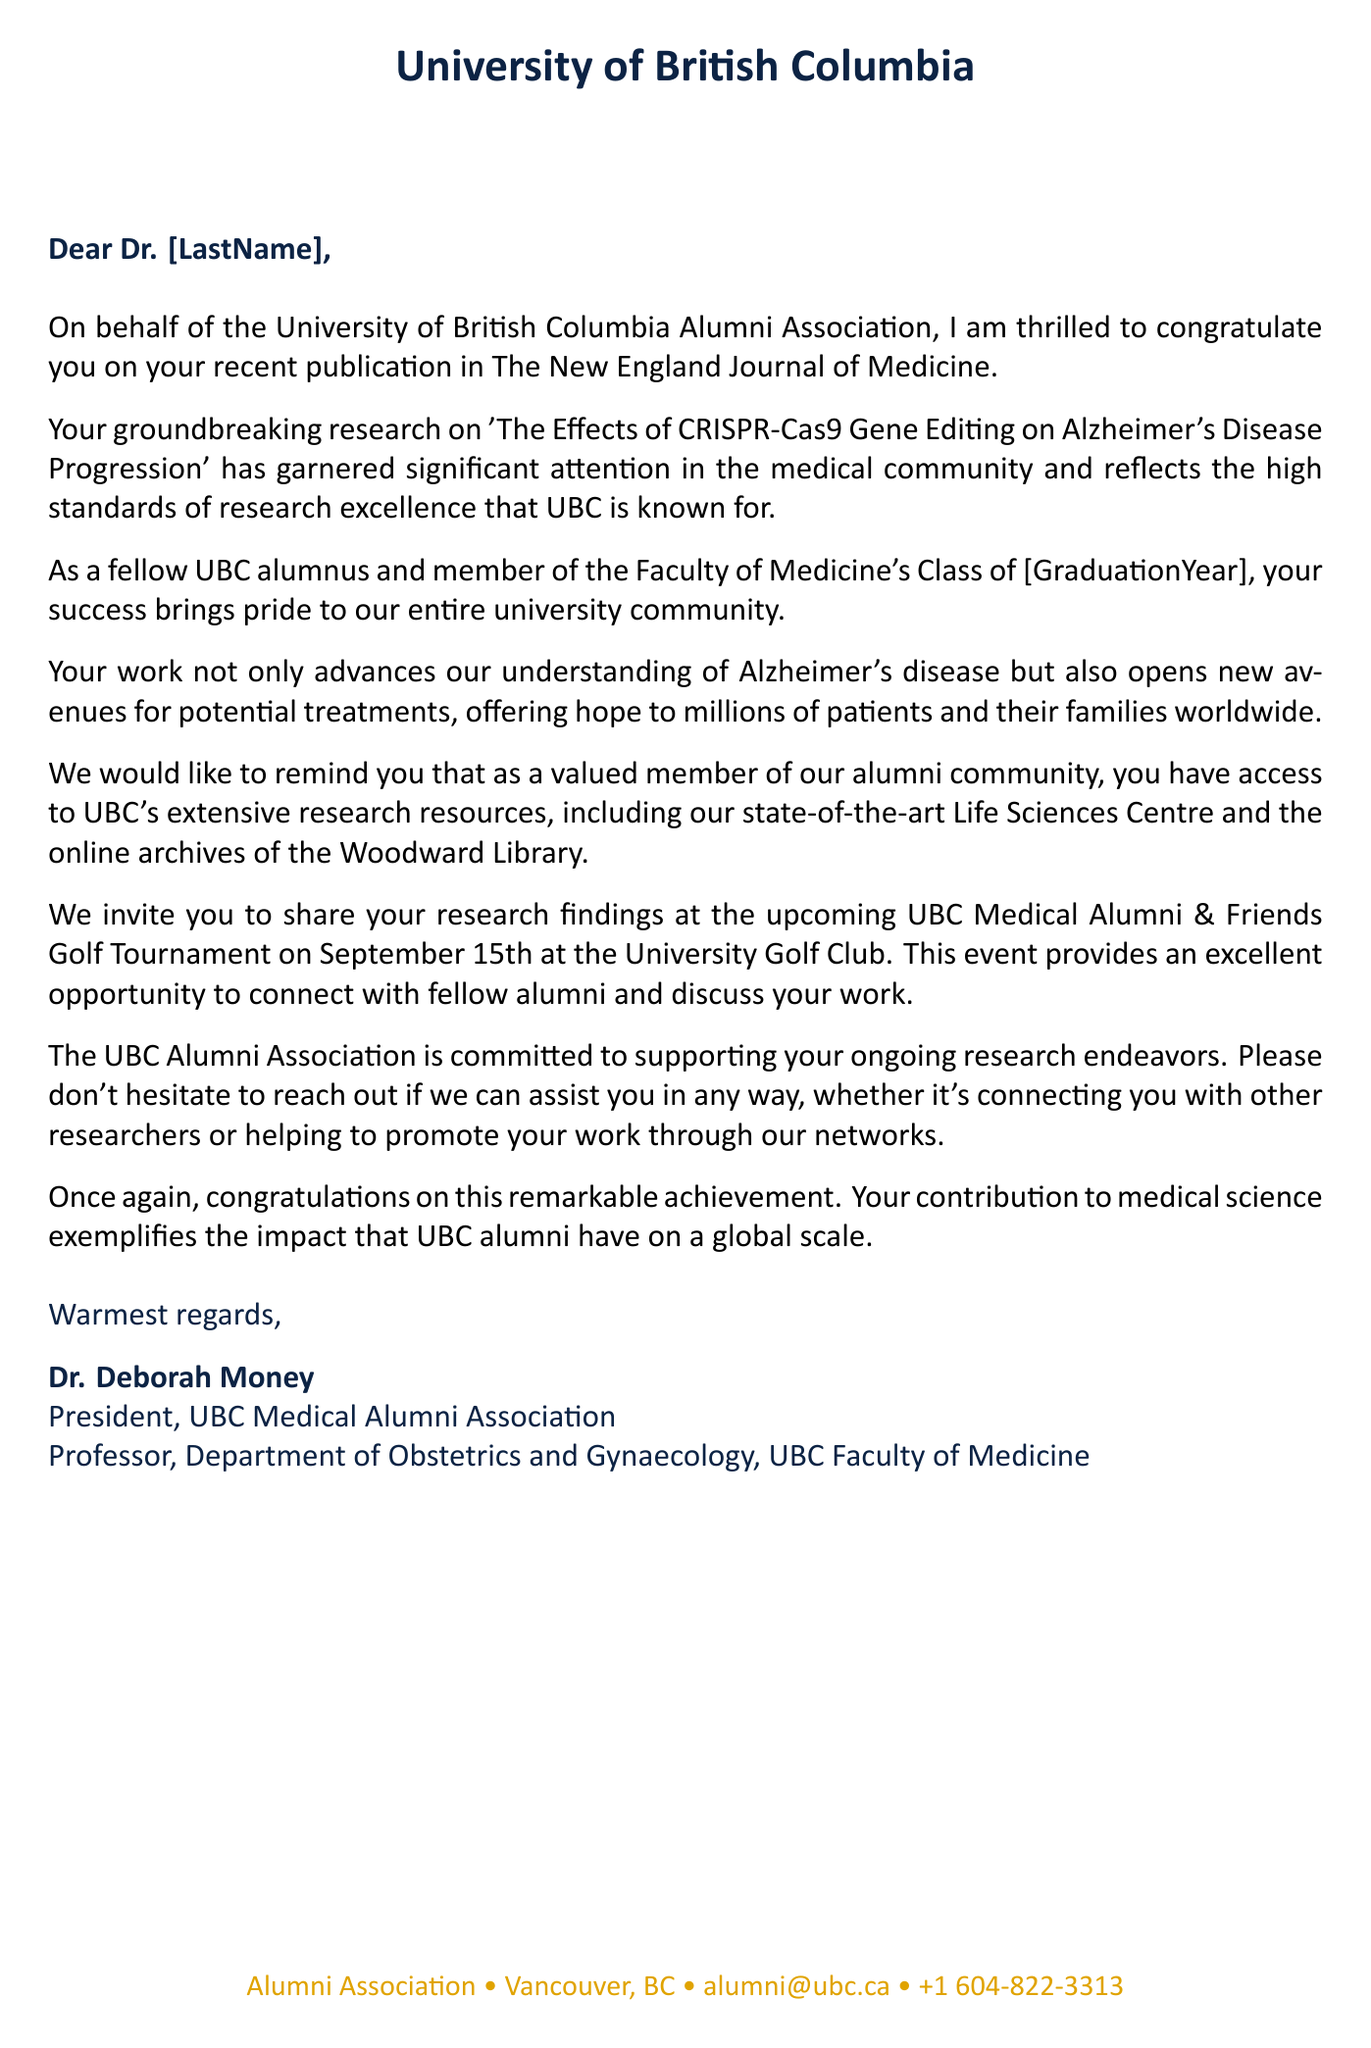What is the salutation of the letter? The salutation is addressed to Dr. [LastName], indicating a formal greeting.
Answer: Dear Dr. [LastName], Who is the President of the UBC Medical Alumni Association? The closing section of the letter identifies Dr. Deborah Money as the president.
Answer: Dr. Deborah Money What is the publication where the research was published? The opening of the letter mentions that the research was published in a specific journal.
Answer: The New England Journal of Medicine What date is the UBC Medical Alumni & Friends Golf Tournament scheduled? The letter invites recipients to an event, specifying its date.
Answer: September 15, 2023 What research facility is mentioned as part of UBC's resources? The letter lists one of the state-of-the-art facilities available to alumni.
Answer: Life Sciences Centre What is the overall theme of the letter? The letter celebrates a significant achievement in the form of a publication, which demonstrates the impact of UBC alumni.
Answer: Congratulations on your publication What is the underlying purpose of inviting the recipient to the golf tournament? The letter explains that the event is intended for networking and discussing research among alumni.
Answer: Networking opportunity What does the letter express regarding the recipient's research? The letter acknowledges the impact and importance of the recipient's research in the medical community.
Answer: Groundbreaking research What is the email address for the UBC Alumni Association? The letter provides contact information for the association, including their email for communication.
Answer: alumni@ubc.ca 